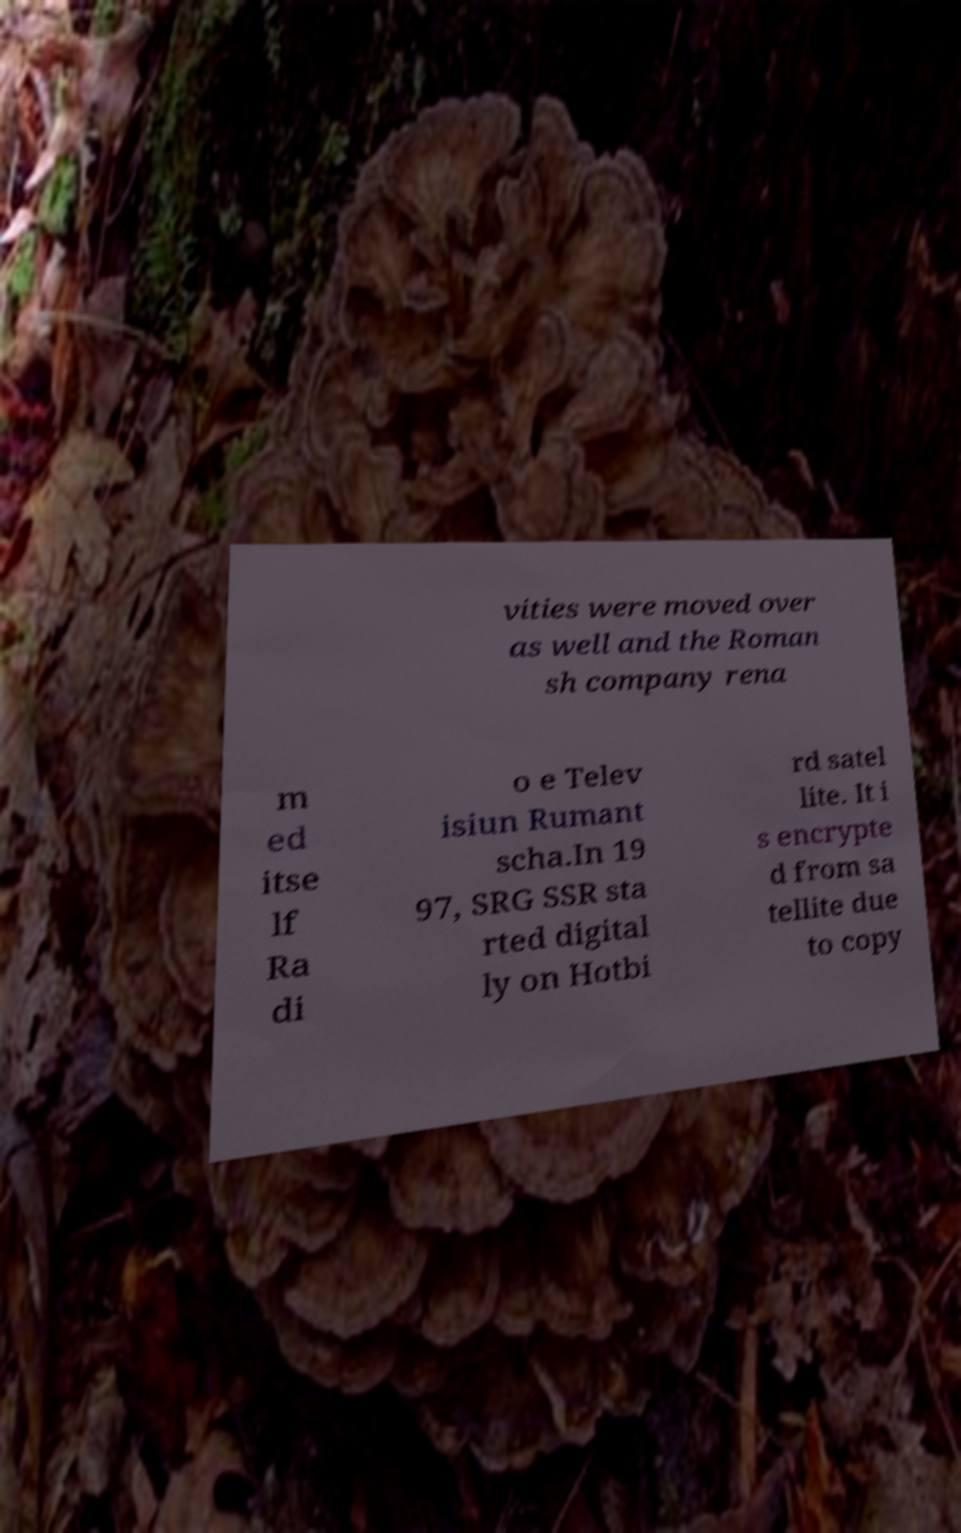Please identify and transcribe the text found in this image. vities were moved over as well and the Roman sh company rena m ed itse lf Ra di o e Telev isiun Rumant scha.In 19 97, SRG SSR sta rted digital ly on Hotbi rd satel lite. It i s encrypte d from sa tellite due to copy 